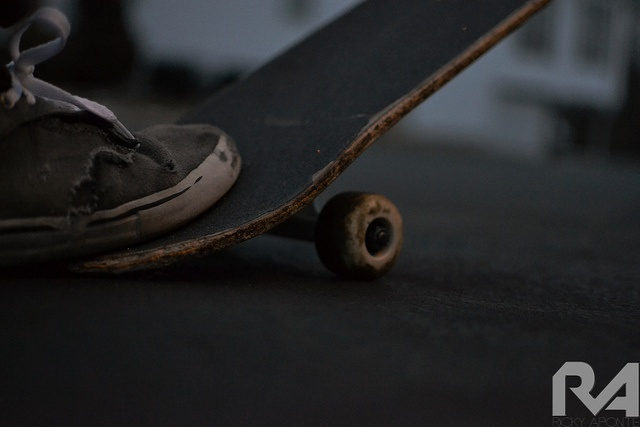Describe the objects in this image and their specific colors. I can see skateboard in black, maroon, and gray tones and people in black and gray tones in this image. 